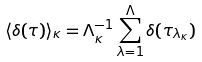Convert formula to latex. <formula><loc_0><loc_0><loc_500><loc_500>\langle \delta ( \tau ) \rangle _ { \kappa } = \Lambda ^ { - 1 } _ { \kappa } \sum _ { \lambda = 1 } ^ { \Lambda } \delta ( \tau _ { \lambda _ { \kappa } } )</formula> 